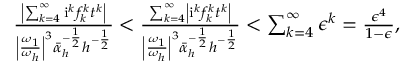<formula> <loc_0><loc_0><loc_500><loc_500>\begin{array} { r l r } & { \frac { \left | \sum _ { k = 4 } ^ { \infty } i ^ { k } f _ { k } ^ { k } t ^ { k } \right | } { \left | \frac { \omega _ { 1 } } { \omega _ { h } } \right | ^ { 3 } \bar { \alpha } _ { h } ^ { - \frac { 1 } { 2 } } h ^ { - \frac { 1 } { 2 } } } < \frac { \sum _ { k = 4 } ^ { \infty } \left | i ^ { k } f _ { k } ^ { k } t ^ { k } \right | } { \left | \frac { \omega _ { 1 } } { \omega _ { h } } \right | ^ { 3 } \bar { \alpha } _ { h } ^ { - \frac { 1 } { 2 } } h ^ { - \frac { 1 } { 2 } } } < \sum _ { k = 4 } ^ { \infty } \epsilon ^ { k } = \frac { \epsilon ^ { 4 } } { 1 - \epsilon } , } \end{array}</formula> 